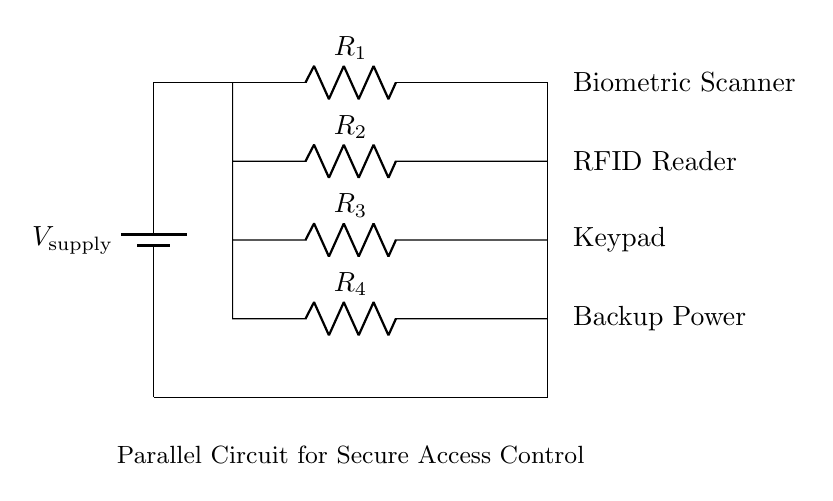What components are present in the circuit? The circuit contains a battery, four resistors, a biometric scanner, an RFID reader, a keypad, and a backup power source. Each component is represented in the diagram, showing how they are interconnected.
Answer: Battery, resistors, biometric scanner, RFID reader, keypad, backup power What is the function of the biometric scanner? The biometric scanner serves as an access control mechanism, verifying identity using unique biological traits like fingerprints or facial recognition. It is connected in parallel to other components, allowing multiple access methods to function independently.
Answer: Identity verification What type of circuit is depicted in this diagram? The circuit shown is a parallel circuit because all components (biometric scanner, RFID reader, keypad, and backup power) are connected side by side, sharing the same voltage across each component while allowing for independent operation.
Answer: Parallel circuit What is the total number of access control methods available? There are four access control methods illustrated in the circuit: the biometric scanner, RFID reader, keypad, and backup power, emphasizing the circuit's redundancy and operational safety.
Answer: Four How does adding more components affect the overall current in this circuit? In a parallel circuit, adding more components increases the total current since each component adds an additional path for the current to flow. More components provide more paths, and the overall resistance decreases, leading to increased total current draw from the supply.
Answer: Increased total current What is the significance of having a backup power source? The backup power source is crucial for ensuring that the access control system remains operational during a power failure. By connecting it in parallel with other access control methods, it guarantees that at least one method can function if the main power is lost.
Answer: Ensures operational continuity What happens if one access control method fails in this circuit? If one access control method fails, the other methods will still continue to function independently due to the parallel configuration. This redundancy is vital for security systems in high-profile locations, ensuring that access is not compromised.
Answer: Other methods continue to function 